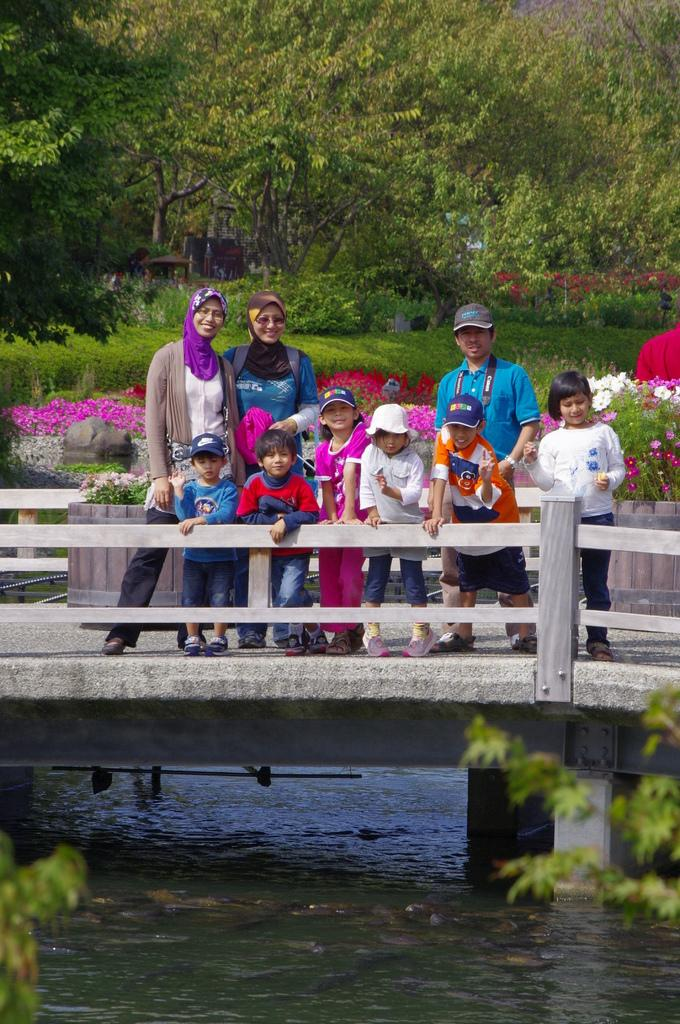What structure can be seen in the image? There is a bridge in the image. Who or what is on the bridge? There is a group of people on the bridge. What is visible under the bridge? There is water visible under the bridge. What can be seen in the background of the image? There are trees in the background of the image. What type of star can be seen in the image? There is no star visible in the image; it features a bridge, a group of people, water, and trees in the background. 